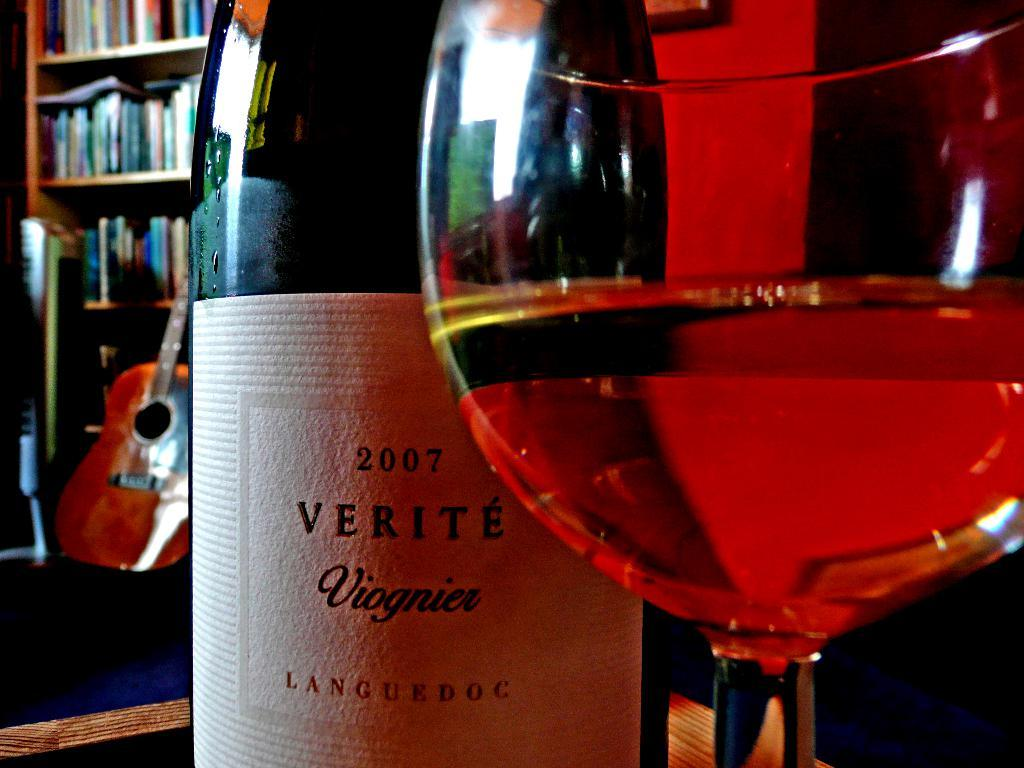Provide a one-sentence caption for the provided image. A bottle of wine from the year 2007 sits behind a full wine glass. 